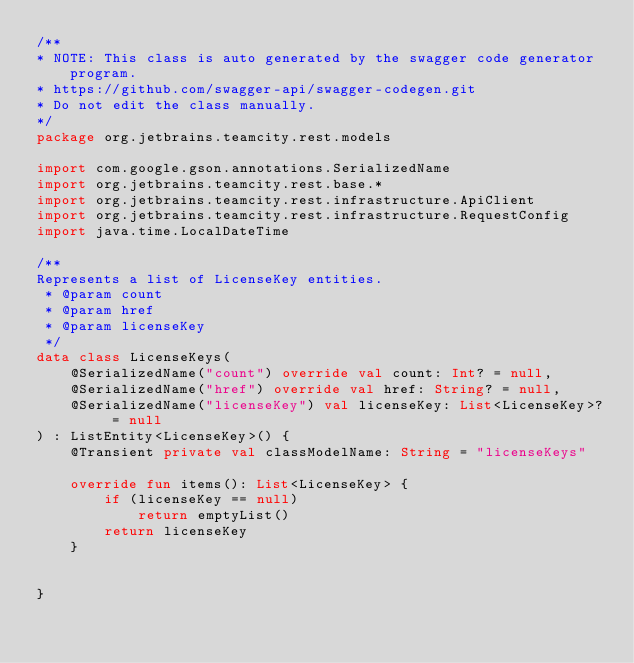<code> <loc_0><loc_0><loc_500><loc_500><_Kotlin_>/**
* NOTE: This class is auto generated by the swagger code generator program.
* https://github.com/swagger-api/swagger-codegen.git
* Do not edit the class manually.
*/
package org.jetbrains.teamcity.rest.models

import com.google.gson.annotations.SerializedName
import org.jetbrains.teamcity.rest.base.*
import org.jetbrains.teamcity.rest.infrastructure.ApiClient
import org.jetbrains.teamcity.rest.infrastructure.RequestConfig
import java.time.LocalDateTime

/**
Represents a list of LicenseKey entities.
 * @param count 
 * @param href 
 * @param licenseKey 
 */
data class LicenseKeys(
    @SerializedName("count") override val count: Int? = null,
    @SerializedName("href") override val href: String? = null,
    @SerializedName("licenseKey") val licenseKey: List<LicenseKey>? = null
) : ListEntity<LicenseKey>() {
    @Transient private val classModelName: String = "licenseKeys"

    override fun items(): List<LicenseKey> {
        if (licenseKey == null)
            return emptyList()
        return licenseKey
    }


}

</code> 